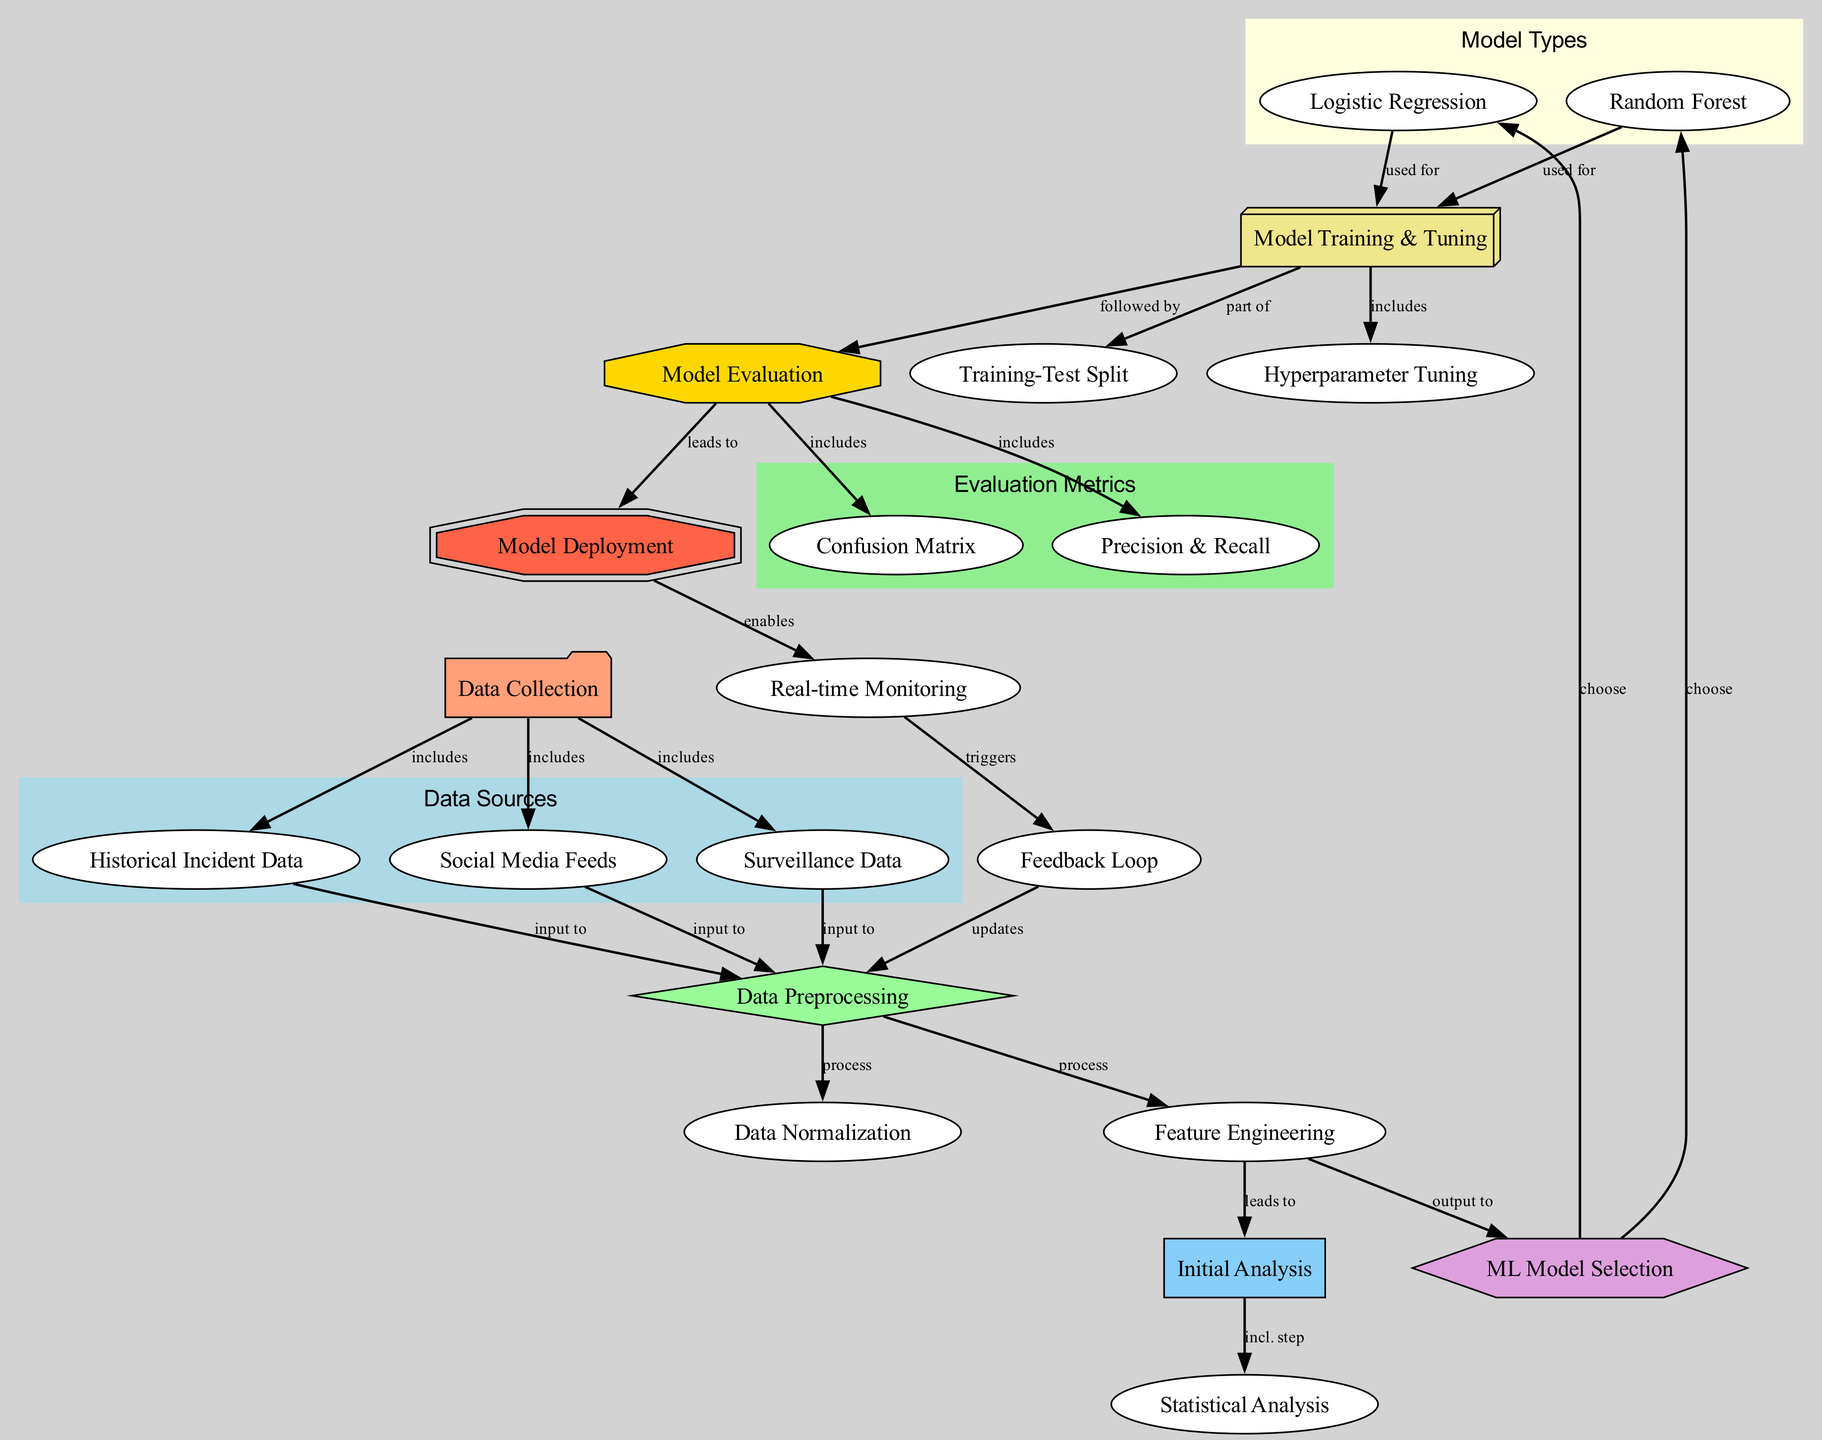What are the three types of data sources in the diagram? The diagram lists three data sources under the “Data Sources” cluster: Historical Incident Data, Social Media Feeds, and Surveillance Data.
Answer: Historical Incident Data, Social Media Feeds, Surveillance Data What is the shape of the 'Model Evaluation' node? The shape of the 'Model Evaluation' node is designated as an octagon in the diagram.
Answer: Octagon Which node leads to 'Model Deployment'? The 'Model Evaluation' node directly leads to the 'Model Deployment' node, indicating that it is the precursor step that allows for deployment after evaluation.
Answer: Model Evaluation How many nodes are there in total? The diagram shows 20 nodes in total, encompassing all components related to the machine learning pipeline for predictive analysis of terrorist activities.
Answer: 20 What is the purpose of the 'Feedback Loop'? The 'Feedback Loop' updates the ‘Data Preprocessing’ based on the insights from real-time monitoring, indicating a cyclical process that enhances the model's accuracy and adaptability.
Answer: Updates Data Preprocessing What two machine learning models are selected in the diagram? The two machine learning models indicated for selection in the diagram are Logistic Regression and Random Forest, both of which are listed under the 'ML Model Selection' node.
Answer: Logistic Regression, Random Forest Explain the relationship between 'Model Training' and 'Hyperparameter Tuning'. The relationship indicates that Hyperparameter Tuning is part of the Model Training process, meaning adjustments to model parameters are made during this phase to improve performance.
Answer: Part of What triggers the 'Feedback Loop' in the diagram? The 'Feedback Loop' is triggered by the 'Real-time Monitoring' node, suggesting that continuous observation and data collection lead to updates in the preprocessing of data.
Answer: Real-time Monitoring Which type of analysis comes immediately before 'Model Evaluation'? The 'Model Training' step immediately precedes 'Model Evaluation' as indicated in the flow of the diagram, showing the sequence in machine learning processes.
Answer: Model Training 